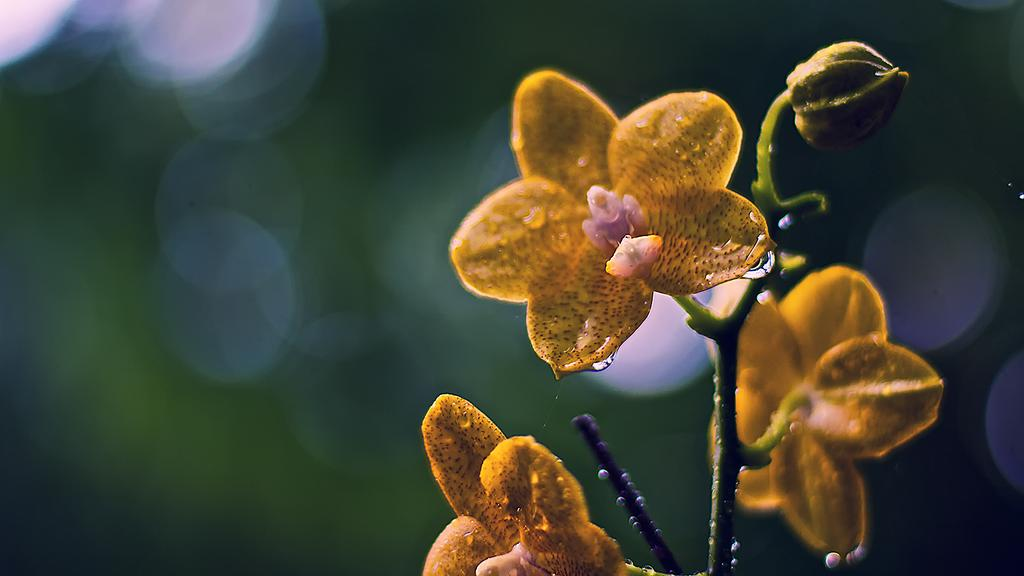What type of flowers can be seen in the front of the image? There are yellow color flowers in the front of the image. Can you describe the background of the image? The background of the image is blurred. How many giants are sitting on the cushion in the image? There are no giants or cushions present in the image. 